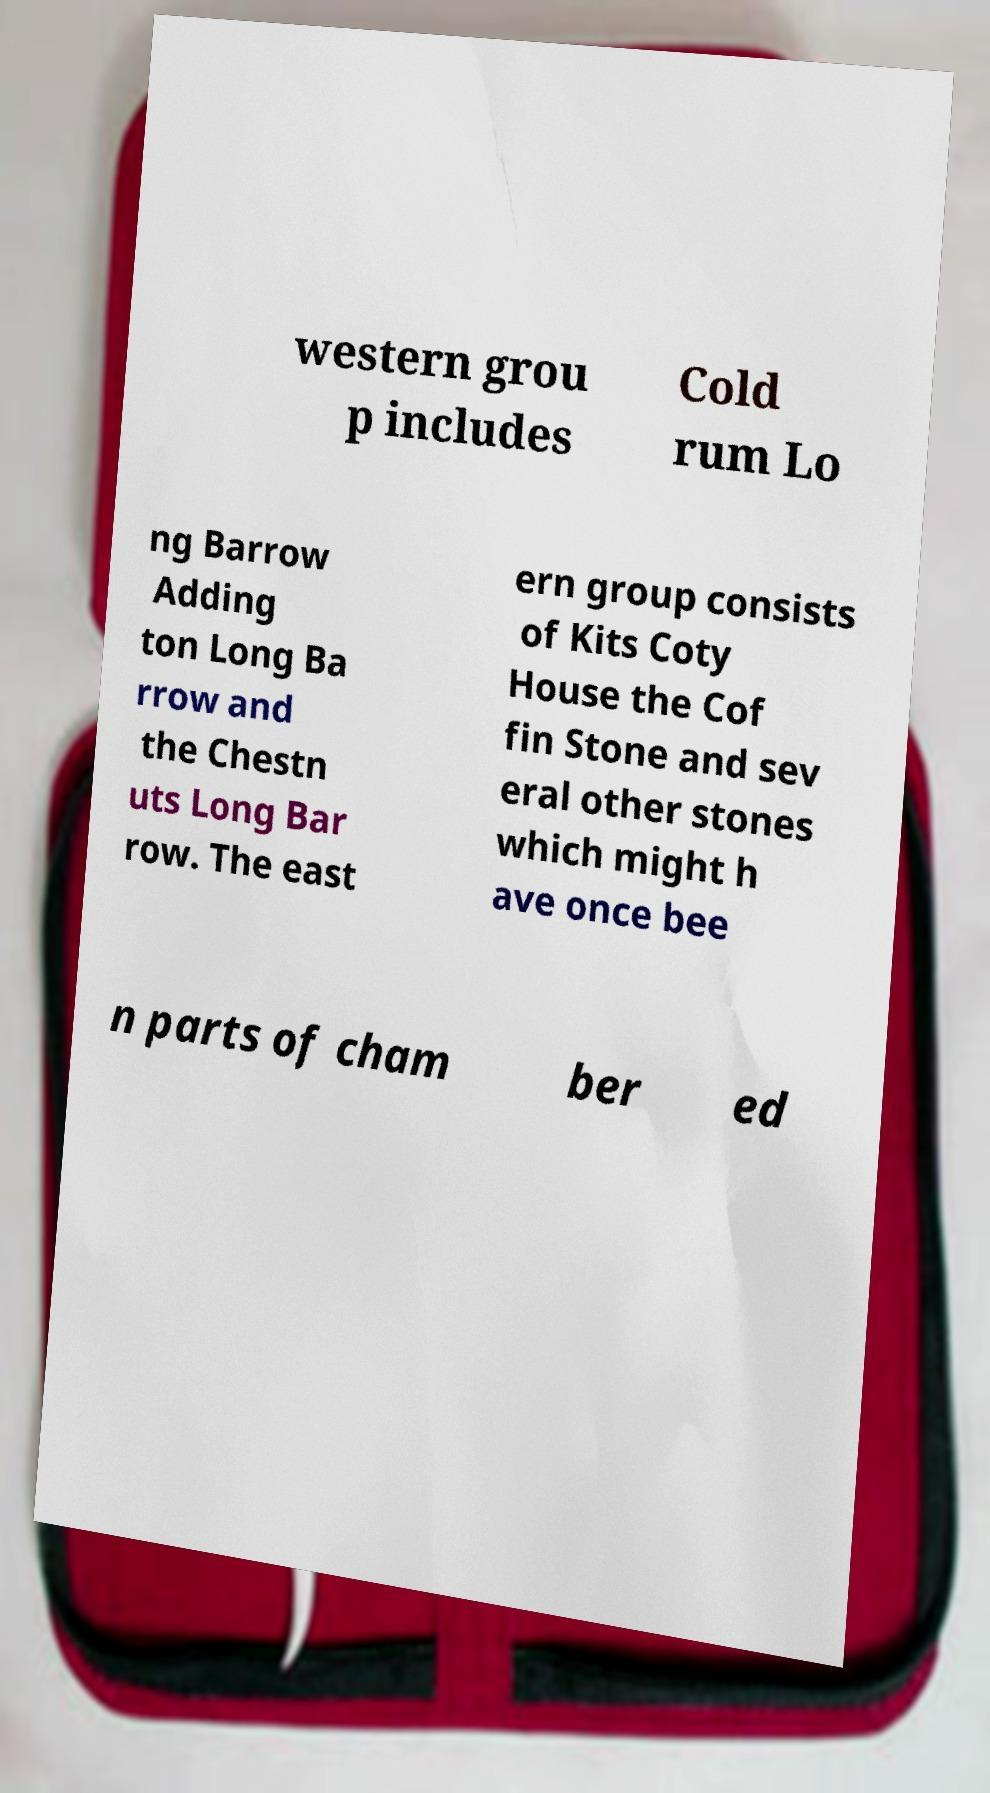What messages or text are displayed in this image? I need them in a readable, typed format. western grou p includes Cold rum Lo ng Barrow Adding ton Long Ba rrow and the Chestn uts Long Bar row. The east ern group consists of Kits Coty House the Cof fin Stone and sev eral other stones which might h ave once bee n parts of cham ber ed 